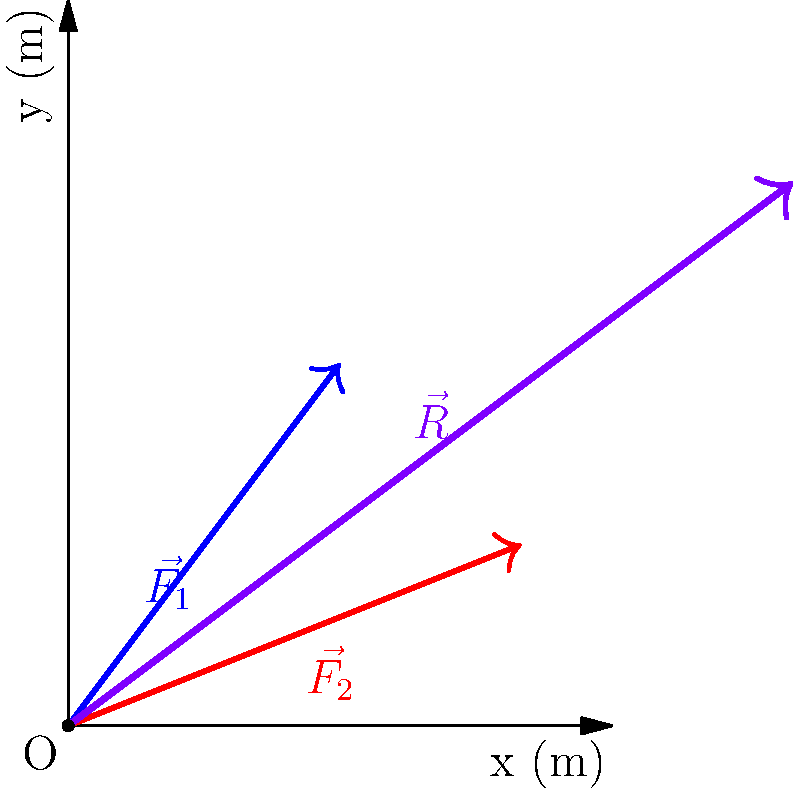An athlete experiences two force vectors during a jump: $\vec{F_1} = 3\hat{i} + 4\hat{j}$ N and $\vec{F_2} = 5\hat{i} + 2\hat{j}$ N. Calculate the magnitude of the resultant force vector $\vec{R}$ acting on the athlete. To find the magnitude of the resultant force vector, we need to follow these steps:

1) The resultant vector $\vec{R}$ is the sum of the two force vectors:
   $\vec{R} = \vec{F_1} + \vec{F_2}$

2) Add the components:
   $\vec{R} = (3\hat{i} + 4\hat{j}) + (5\hat{i} + 2\hat{j})$
   $\vec{R} = (3+5)\hat{i} + (4+2)\hat{j}$
   $\vec{R} = 8\hat{i} + 6\hat{j}$

3) The magnitude of $\vec{R}$ is given by the Pythagorean theorem:
   $|\vec{R}| = \sqrt{R_x^2 + R_y^2}$

4) Substitute the values:
   $|\vec{R}| = \sqrt{8^2 + 6^2}$

5) Calculate:
   $|\vec{R}| = \sqrt{64 + 36} = \sqrt{100} = 10$

Therefore, the magnitude of the resultant force vector is 10 N.
Answer: 10 N 